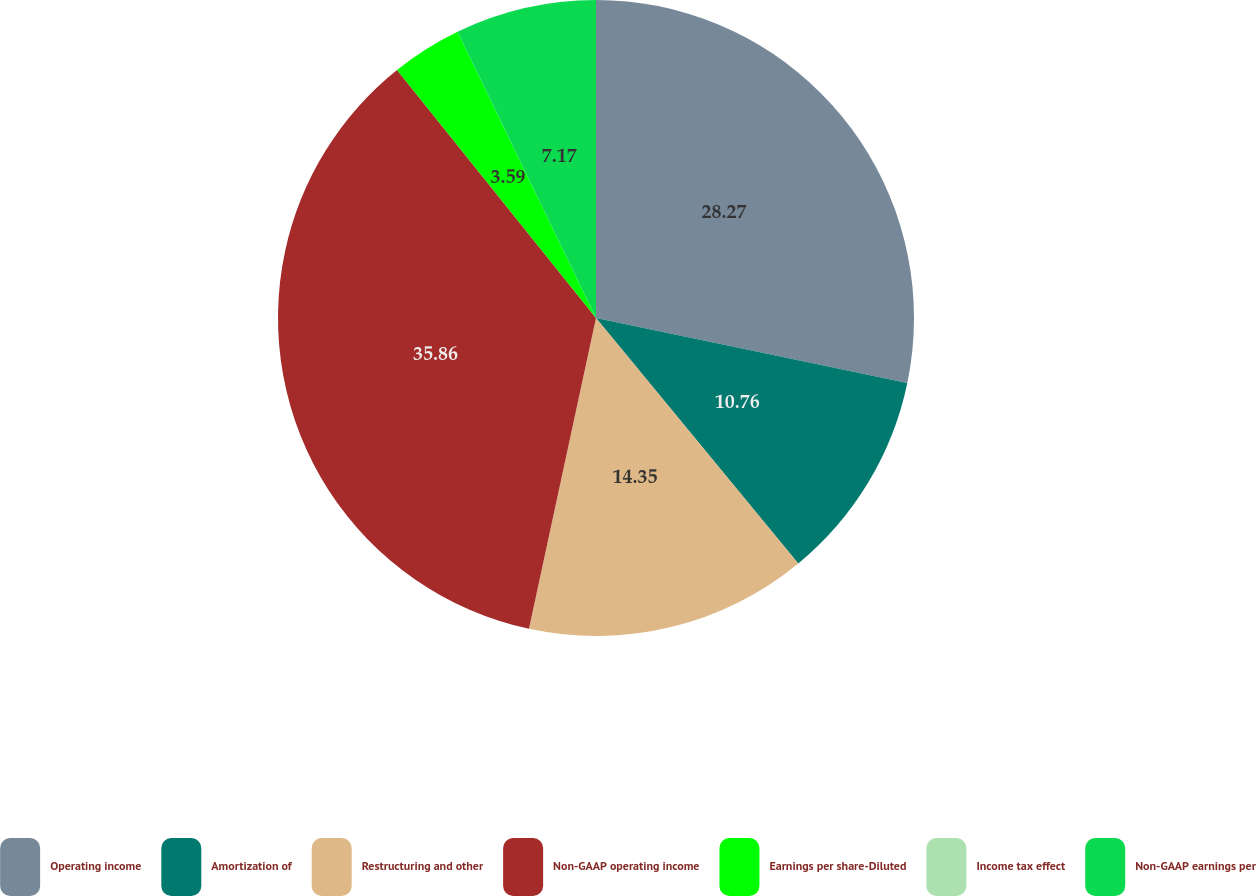Convert chart to OTSL. <chart><loc_0><loc_0><loc_500><loc_500><pie_chart><fcel>Operating income<fcel>Amortization of<fcel>Restructuring and other<fcel>Non-GAAP operating income<fcel>Earnings per share-Diluted<fcel>Income tax effect<fcel>Non-GAAP earnings per<nl><fcel>28.27%<fcel>10.76%<fcel>14.35%<fcel>35.86%<fcel>3.59%<fcel>0.0%<fcel>7.17%<nl></chart> 